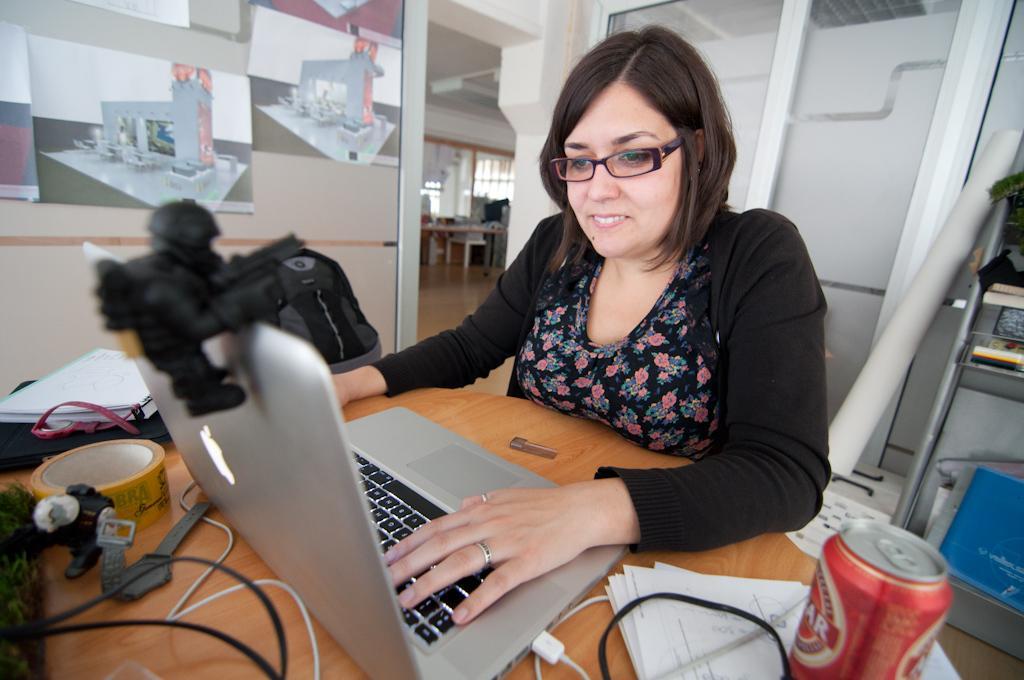How would you summarize this image in a sentence or two? In this image, woman in black dress. She wear glasses. In-front of her, there is a wooden table, laptop. Few items are placed on it. And back side, we can see chart, glass doors. On left side, we can see some photo. And back side, there is an another table, few items are placed on it. Right side, there is an iron table. Few items are viewed. 